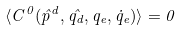<formula> <loc_0><loc_0><loc_500><loc_500>\langle C ^ { 0 } ( \hat { p } ^ { d } , \hat { q _ { d } } , q _ { e } , \dot { q } _ { e } ) \rangle = 0</formula> 